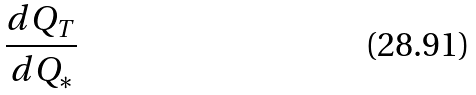<formula> <loc_0><loc_0><loc_500><loc_500>\frac { d Q _ { T } } { d Q _ { * } }</formula> 